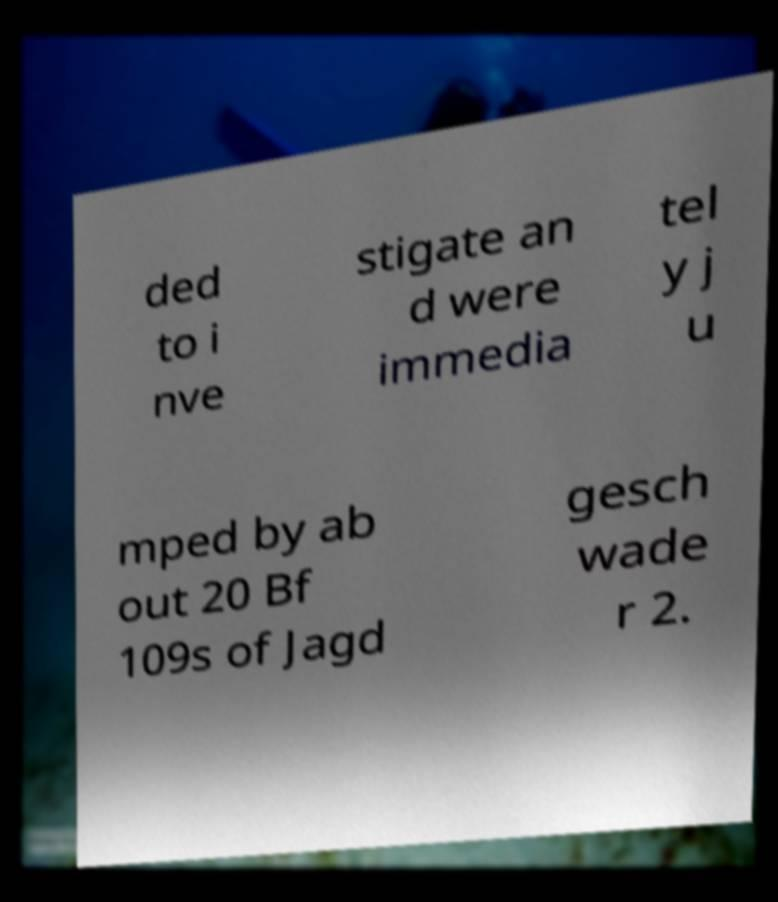Please read and relay the text visible in this image. What does it say? ded to i nve stigate an d were immedia tel y j u mped by ab out 20 Bf 109s of Jagd gesch wade r 2. 